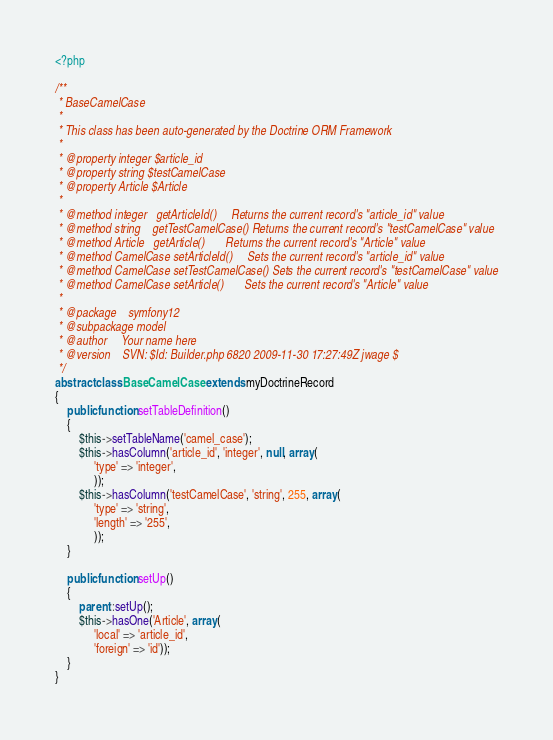Convert code to text. <code><loc_0><loc_0><loc_500><loc_500><_PHP_><?php

/**
 * BaseCamelCase
 * 
 * This class has been auto-generated by the Doctrine ORM Framework
 * 
 * @property integer $article_id
 * @property string $testCamelCase
 * @property Article $Article
 * 
 * @method integer   getArticleId()     Returns the current record's "article_id" value
 * @method string    getTestCamelCase() Returns the current record's "testCamelCase" value
 * @method Article   getArticle()       Returns the current record's "Article" value
 * @method CamelCase setArticleId()     Sets the current record's "article_id" value
 * @method CamelCase setTestCamelCase() Sets the current record's "testCamelCase" value
 * @method CamelCase setArticle()       Sets the current record's "Article" value
 * 
 * @package    symfony12
 * @subpackage model
 * @author     Your name here
 * @version    SVN: $Id: Builder.php 6820 2009-11-30 17:27:49Z jwage $
 */
abstract class BaseCamelCase extends myDoctrineRecord
{
    public function setTableDefinition()
    {
        $this->setTableName('camel_case');
        $this->hasColumn('article_id', 'integer', null, array(
             'type' => 'integer',
             ));
        $this->hasColumn('testCamelCase', 'string', 255, array(
             'type' => 'string',
             'length' => '255',
             ));
    }

    public function setUp()
    {
        parent::setUp();
        $this->hasOne('Article', array(
             'local' => 'article_id',
             'foreign' => 'id'));
    }
}</code> 